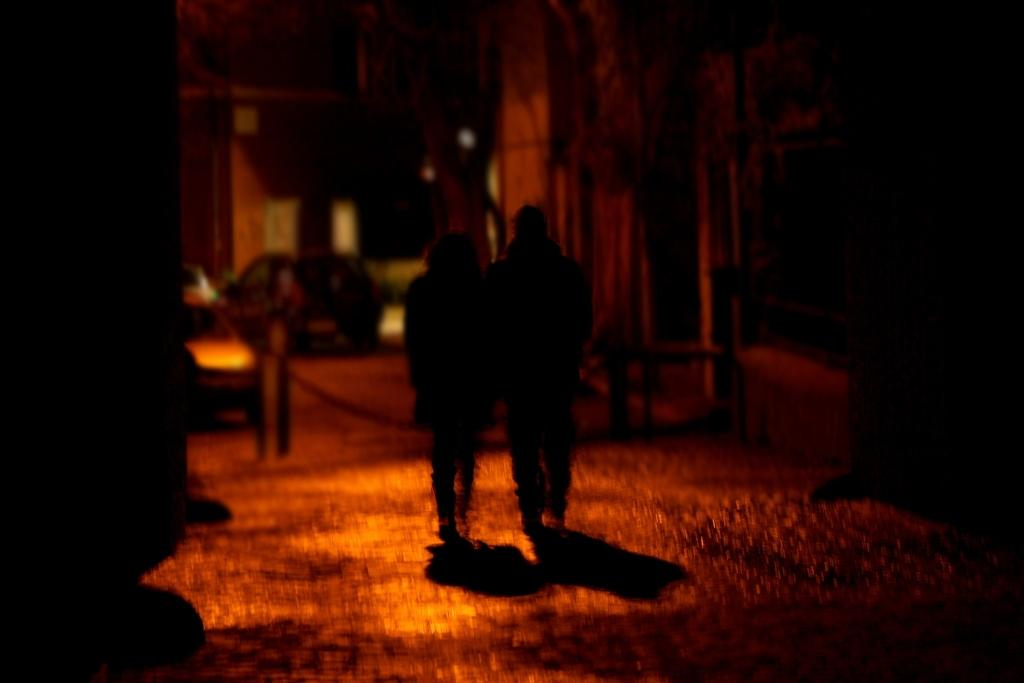What are the main subjects in the image? There are persons walking in the center of the image. What can be seen in the background of the image? There are cars and buildings in the background of the image. What type of crate is being used to attract the attention of the persons walking in the image? There is no crate present in the image, and the persons walking are not being attracted by any object. 